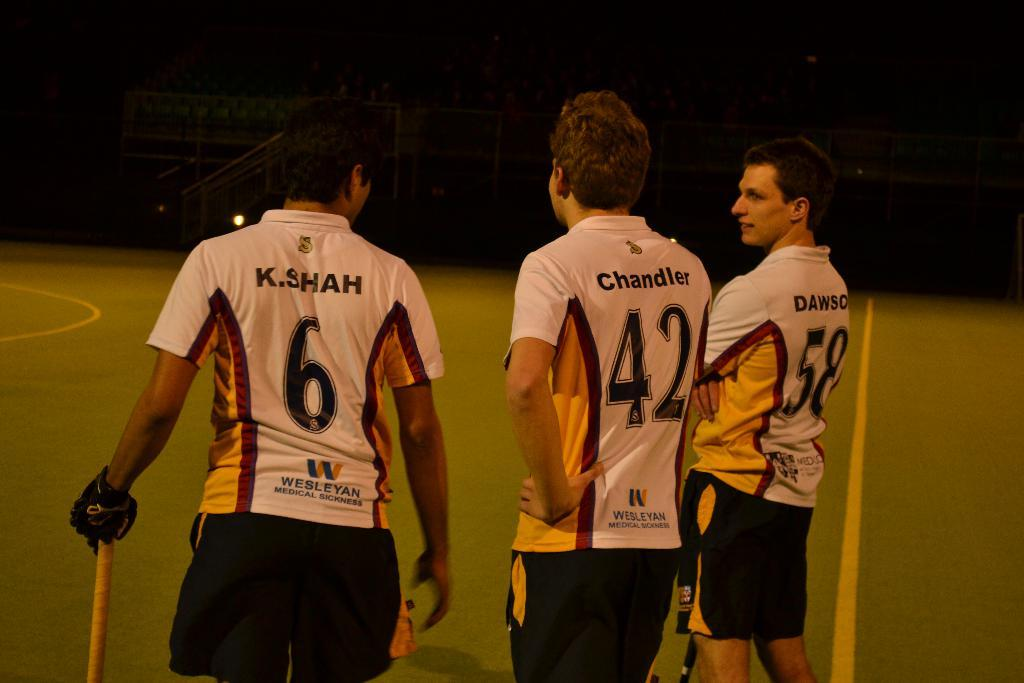<image>
Write a terse but informative summary of the picture. thre players including one with the number 42 on their back 